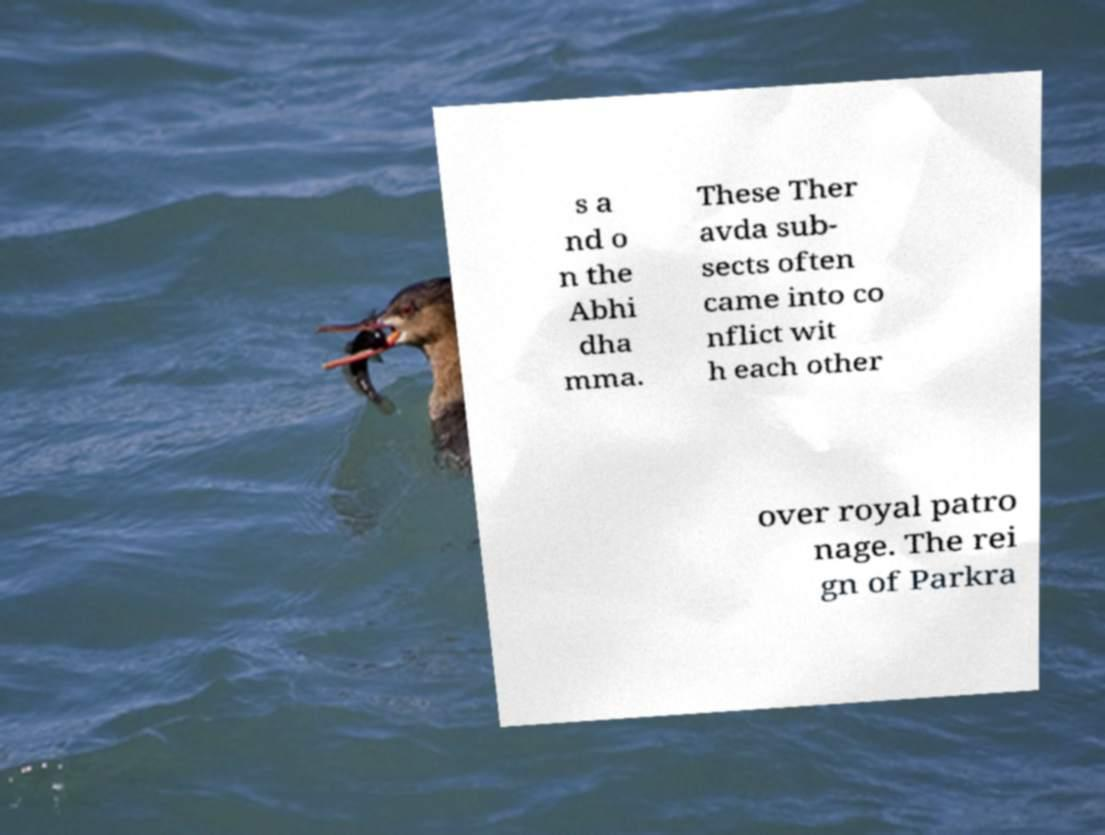Please identify and transcribe the text found in this image. s a nd o n the Abhi dha mma. These Ther avda sub- sects often came into co nflict wit h each other over royal patro nage. The rei gn of Parkra 